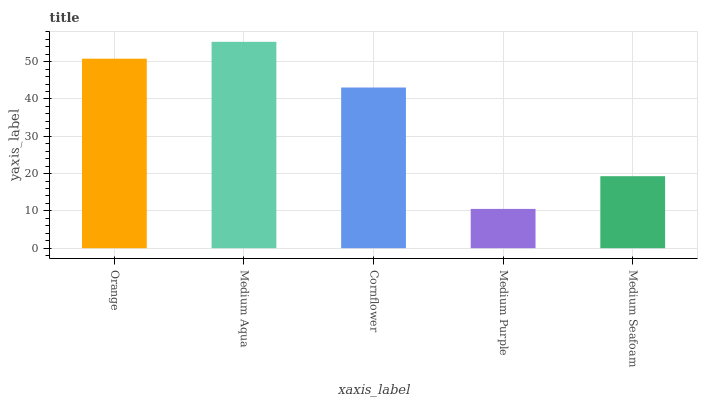Is Medium Purple the minimum?
Answer yes or no. Yes. Is Medium Aqua the maximum?
Answer yes or no. Yes. Is Cornflower the minimum?
Answer yes or no. No. Is Cornflower the maximum?
Answer yes or no. No. Is Medium Aqua greater than Cornflower?
Answer yes or no. Yes. Is Cornflower less than Medium Aqua?
Answer yes or no. Yes. Is Cornflower greater than Medium Aqua?
Answer yes or no. No. Is Medium Aqua less than Cornflower?
Answer yes or no. No. Is Cornflower the high median?
Answer yes or no. Yes. Is Cornflower the low median?
Answer yes or no. Yes. Is Medium Purple the high median?
Answer yes or no. No. Is Medium Seafoam the low median?
Answer yes or no. No. 